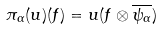<formula> <loc_0><loc_0><loc_500><loc_500>\pi _ { \alpha } ( u ) ( f ) = u ( f \otimes \overline { \psi _ { \alpha } } )</formula> 